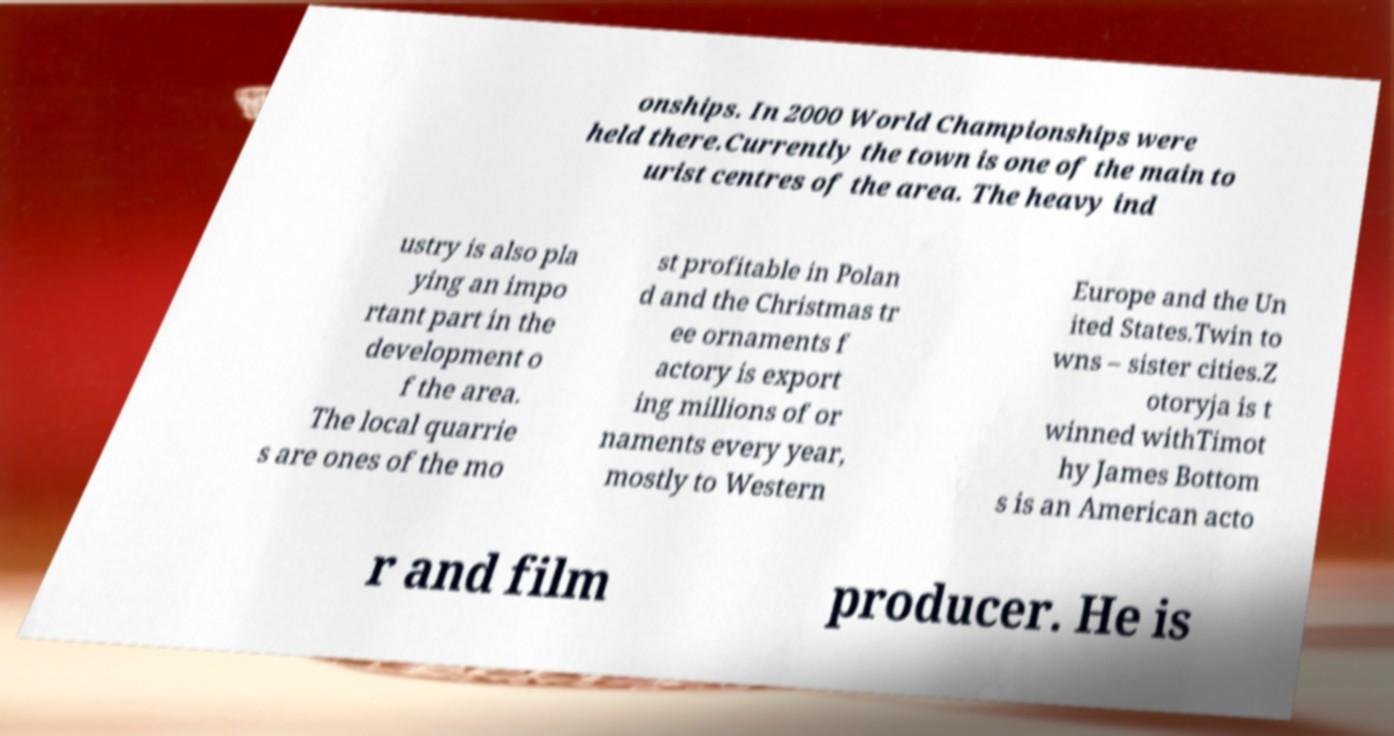I need the written content from this picture converted into text. Can you do that? onships. In 2000 World Championships were held there.Currently the town is one of the main to urist centres of the area. The heavy ind ustry is also pla ying an impo rtant part in the development o f the area. The local quarrie s are ones of the mo st profitable in Polan d and the Christmas tr ee ornaments f actory is export ing millions of or naments every year, mostly to Western Europe and the Un ited States.Twin to wns – sister cities.Z otoryja is t winned withTimot hy James Bottom s is an American acto r and film producer. He is 